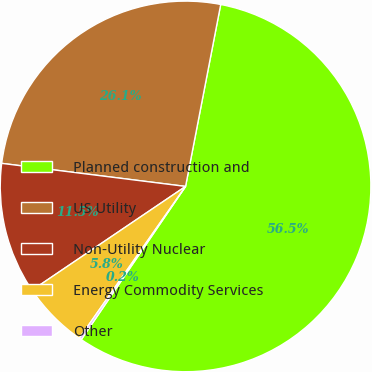Convert chart to OTSL. <chart><loc_0><loc_0><loc_500><loc_500><pie_chart><fcel>Planned construction and<fcel>US Utility<fcel>Non-Utility Nuclear<fcel>Energy Commodity Services<fcel>Other<nl><fcel>56.47%<fcel>26.05%<fcel>11.45%<fcel>5.82%<fcel>0.2%<nl></chart> 